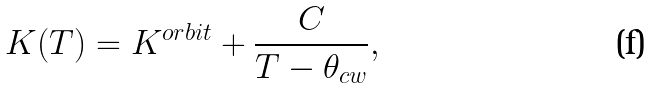<formula> <loc_0><loc_0><loc_500><loc_500>K ( T ) = K ^ { o r b i t } + \frac { C } { T - \theta _ { c w } } ,</formula> 